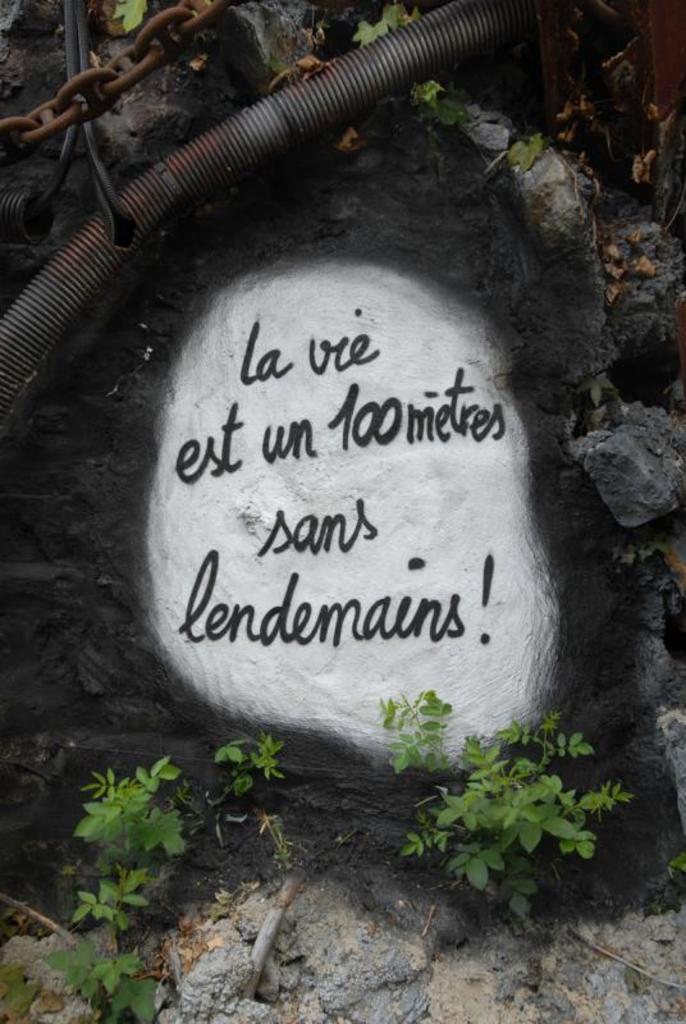In one or two sentences, can you explain what this image depicts? In this image I can see some text written on a stone. Also there are plants, an iron chain, cables and some objects. 